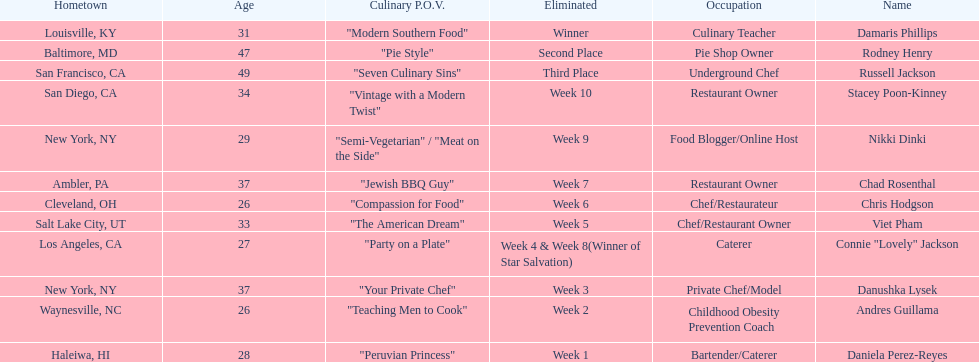Who was the top chef? Damaris Phillips. Can you give me this table as a dict? {'header': ['Hometown', 'Age', 'Culinary P.O.V.', 'Eliminated', 'Occupation', 'Name'], 'rows': [['Louisville, KY', '31', '"Modern Southern Food"', 'Winner', 'Culinary Teacher', 'Damaris Phillips'], ['Baltimore, MD', '47', '"Pie Style"', 'Second Place', 'Pie Shop Owner', 'Rodney Henry'], ['San Francisco, CA', '49', '"Seven Culinary Sins"', 'Third Place', 'Underground Chef', 'Russell Jackson'], ['San Diego, CA', '34', '"Vintage with a Modern Twist"', 'Week 10', 'Restaurant Owner', 'Stacey Poon-Kinney'], ['New York, NY', '29', '"Semi-Vegetarian" / "Meat on the Side"', 'Week 9', 'Food Blogger/Online Host', 'Nikki Dinki'], ['Ambler, PA', '37', '"Jewish BBQ Guy"', 'Week 7', 'Restaurant Owner', 'Chad Rosenthal'], ['Cleveland, OH', '26', '"Compassion for Food"', 'Week 6', 'Chef/Restaurateur', 'Chris Hodgson'], ['Salt Lake City, UT', '33', '"The American Dream"', 'Week 5', 'Chef/Restaurant Owner', 'Viet Pham'], ['Los Angeles, CA', '27', '"Party on a Plate"', 'Week 4 & Week 8(Winner of Star Salvation)', 'Caterer', 'Connie "Lovely" Jackson'], ['New York, NY', '37', '"Your Private Chef"', 'Week 3', 'Private Chef/Model', 'Danushka Lysek'], ['Waynesville, NC', '26', '"Teaching Men to Cook"', 'Week 2', 'Childhood Obesity Prevention Coach', 'Andres Guillama'], ['Haleiwa, HI', '28', '"Peruvian Princess"', 'Week 1', 'Bartender/Caterer', 'Daniela Perez-Reyes']]} 